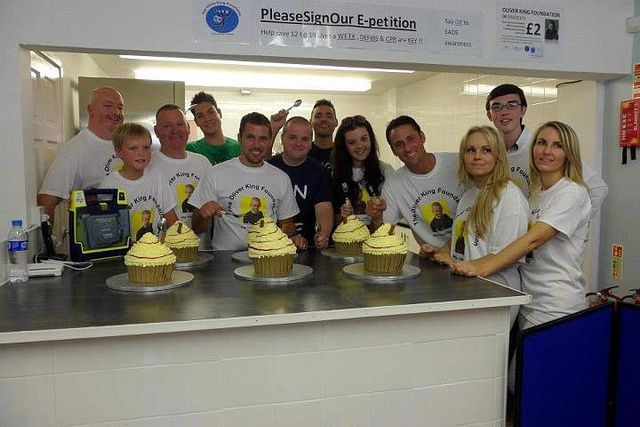Describe the objects in this image and their specific colors. I can see people in gray, darkgray, and maroon tones, people in gray, black, and maroon tones, people in gray, olive, and darkgray tones, people in gray, black, and maroon tones, and people in gray, brown, and maroon tones in this image. 